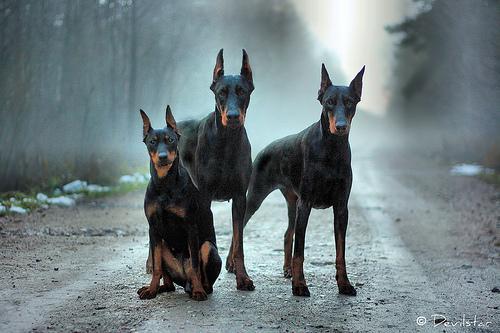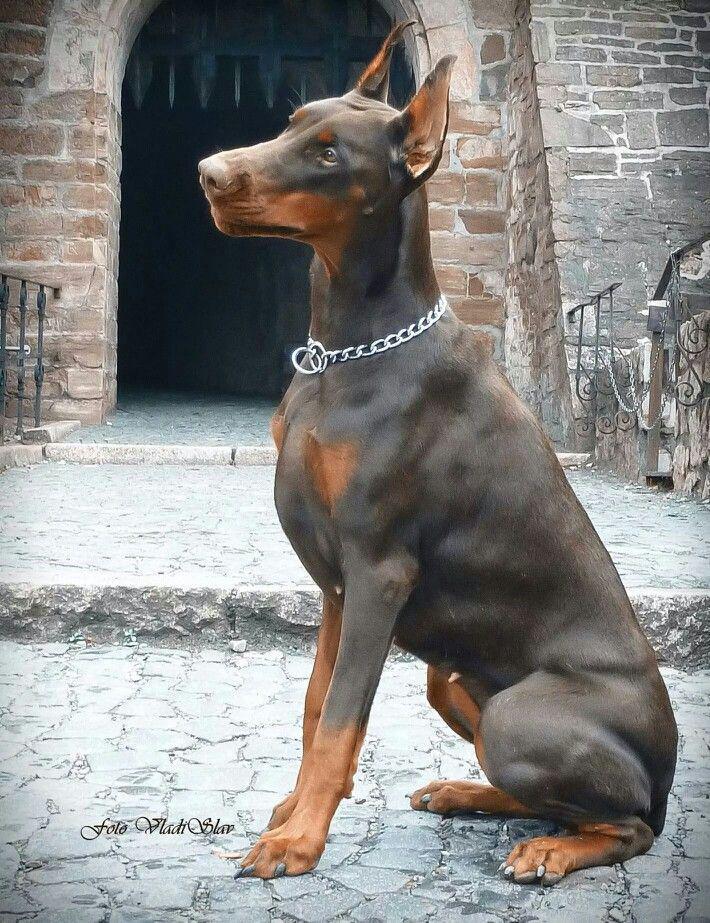The first image is the image on the left, the second image is the image on the right. Analyze the images presented: Is the assertion "The right image features a pointy-eared black-and-tan doberman with docked tail standing with its body turned leftward." valid? Answer yes or no. No. The first image is the image on the left, the second image is the image on the right. Analyze the images presented: Is the assertion "There is only one dog with a collar" valid? Answer yes or no. Yes. 